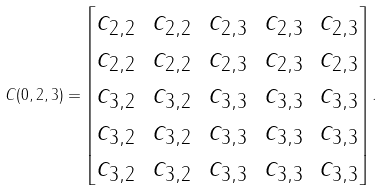Convert formula to latex. <formula><loc_0><loc_0><loc_500><loc_500>C ( 0 , 2 , 3 ) = \begin{bmatrix} c _ { 2 , 2 } & c _ { 2 , 2 } & c _ { 2 , 3 } & c _ { 2 , 3 } & c _ { 2 , 3 } \\ c _ { 2 , 2 } & c _ { 2 , 2 } & c _ { 2 , 3 } & c _ { 2 , 3 } & c _ { 2 , 3 } \\ c _ { 3 , 2 } & c _ { 3 , 2 } & c _ { 3 , 3 } & c _ { 3 , 3 } & c _ { 3 , 3 } \\ c _ { 3 , 2 } & c _ { 3 , 2 } & c _ { 3 , 3 } & c _ { 3 , 3 } & c _ { 3 , 3 } \\ c _ { 3 , 2 } & c _ { 3 , 2 } & c _ { 3 , 3 } & c _ { 3 , 3 } & c _ { 3 , 3 } \end{bmatrix} .</formula> 